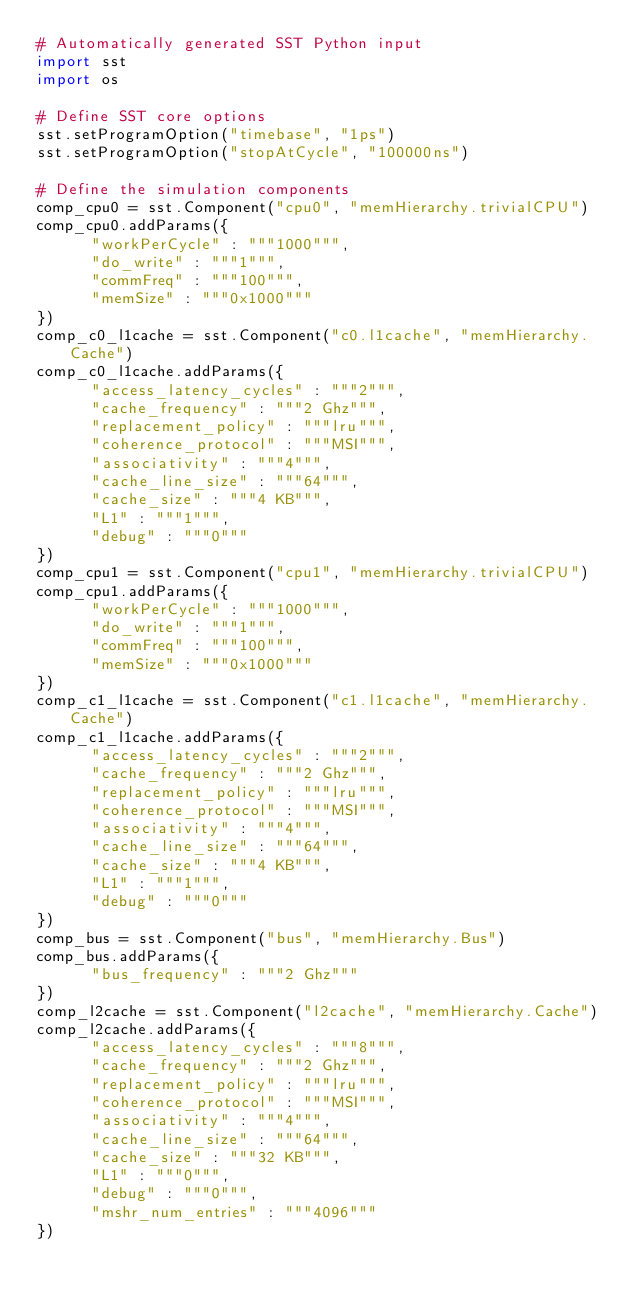Convert code to text. <code><loc_0><loc_0><loc_500><loc_500><_Python_># Automatically generated SST Python input
import sst
import os

# Define SST core options
sst.setProgramOption("timebase", "1ps")
sst.setProgramOption("stopAtCycle", "100000ns")

# Define the simulation components
comp_cpu0 = sst.Component("cpu0", "memHierarchy.trivialCPU")
comp_cpu0.addParams({
      "workPerCycle" : """1000""",
      "do_write" : """1""",
      "commFreq" : """100""",
      "memSize" : """0x1000"""
})
comp_c0_l1cache = sst.Component("c0.l1cache", "memHierarchy.Cache")
comp_c0_l1cache.addParams({
      "access_latency_cycles" : """2""",
      "cache_frequency" : """2 Ghz""",
      "replacement_policy" : """lru""",
      "coherence_protocol" : """MSI""",
      "associativity" : """4""",
      "cache_line_size" : """64""",
      "cache_size" : """4 KB""",
      "L1" : """1""",
      "debug" : """0"""
})
comp_cpu1 = sst.Component("cpu1", "memHierarchy.trivialCPU")
comp_cpu1.addParams({
      "workPerCycle" : """1000""",
      "do_write" : """1""",
      "commFreq" : """100""",
      "memSize" : """0x1000"""
})
comp_c1_l1cache = sst.Component("c1.l1cache", "memHierarchy.Cache")
comp_c1_l1cache.addParams({
      "access_latency_cycles" : """2""",
      "cache_frequency" : """2 Ghz""",
      "replacement_policy" : """lru""",
      "coherence_protocol" : """MSI""",
      "associativity" : """4""",
      "cache_line_size" : """64""",
      "cache_size" : """4 KB""",
      "L1" : """1""",
      "debug" : """0"""
})
comp_bus = sst.Component("bus", "memHierarchy.Bus")
comp_bus.addParams({
      "bus_frequency" : """2 Ghz"""
})
comp_l2cache = sst.Component("l2cache", "memHierarchy.Cache")
comp_l2cache.addParams({
      "access_latency_cycles" : """8""",
      "cache_frequency" : """2 Ghz""",
      "replacement_policy" : """lru""",
      "coherence_protocol" : """MSI""",
      "associativity" : """4""",
      "cache_line_size" : """64""",
      "cache_size" : """32 KB""",
      "L1" : """0""",
      "debug" : """0""",
      "mshr_num_entries" : """4096"""
})</code> 